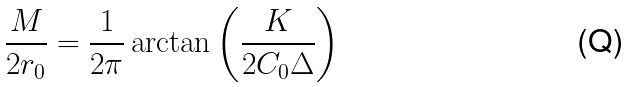Convert formula to latex. <formula><loc_0><loc_0><loc_500><loc_500>\frac { M } { 2 r _ { 0 } } = \frac { 1 } { 2 \pi } \arctan \left ( \frac { K } { 2 C _ { 0 } \Delta } \right )</formula> 